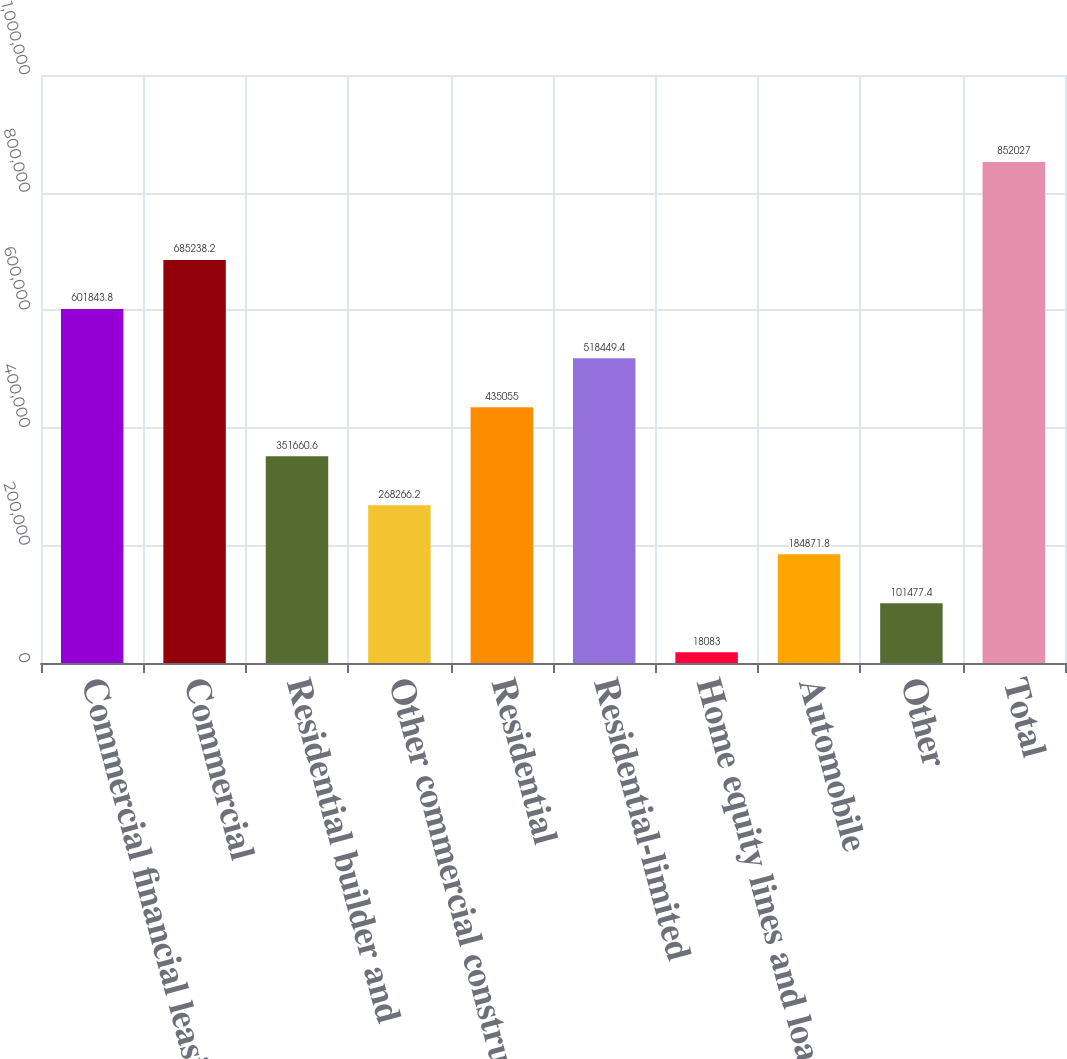Convert chart to OTSL. <chart><loc_0><loc_0><loc_500><loc_500><bar_chart><fcel>Commercial financial leasing<fcel>Commercial<fcel>Residential builder and<fcel>Other commercial construction<fcel>Residential<fcel>Residential-limited<fcel>Home equity lines and loans<fcel>Automobile<fcel>Other<fcel>Total<nl><fcel>601844<fcel>685238<fcel>351661<fcel>268266<fcel>435055<fcel>518449<fcel>18083<fcel>184872<fcel>101477<fcel>852027<nl></chart> 